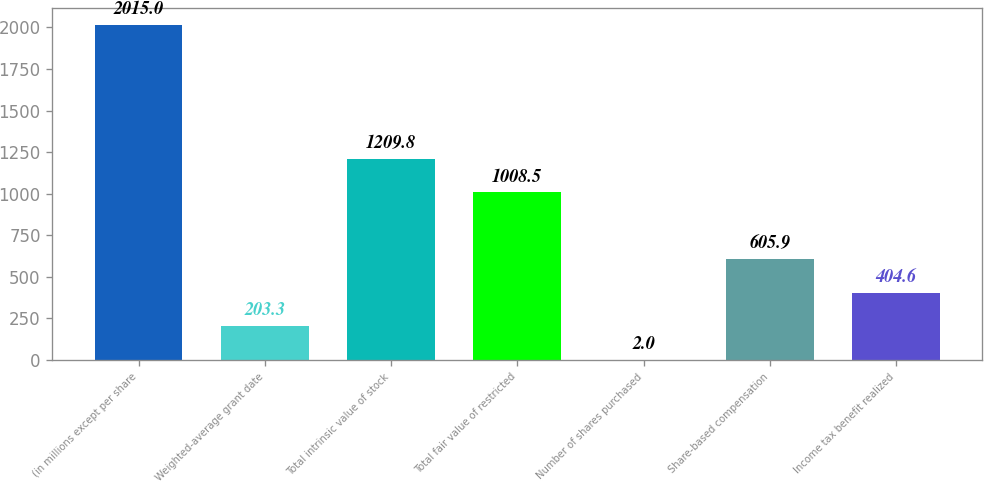Convert chart. <chart><loc_0><loc_0><loc_500><loc_500><bar_chart><fcel>(in millions except per share<fcel>Weighted-average grant date<fcel>Total intrinsic value of stock<fcel>Total fair value of restricted<fcel>Number of shares purchased<fcel>Share-based compensation<fcel>Income tax benefit realized<nl><fcel>2015<fcel>203.3<fcel>1209.8<fcel>1008.5<fcel>2<fcel>605.9<fcel>404.6<nl></chart> 